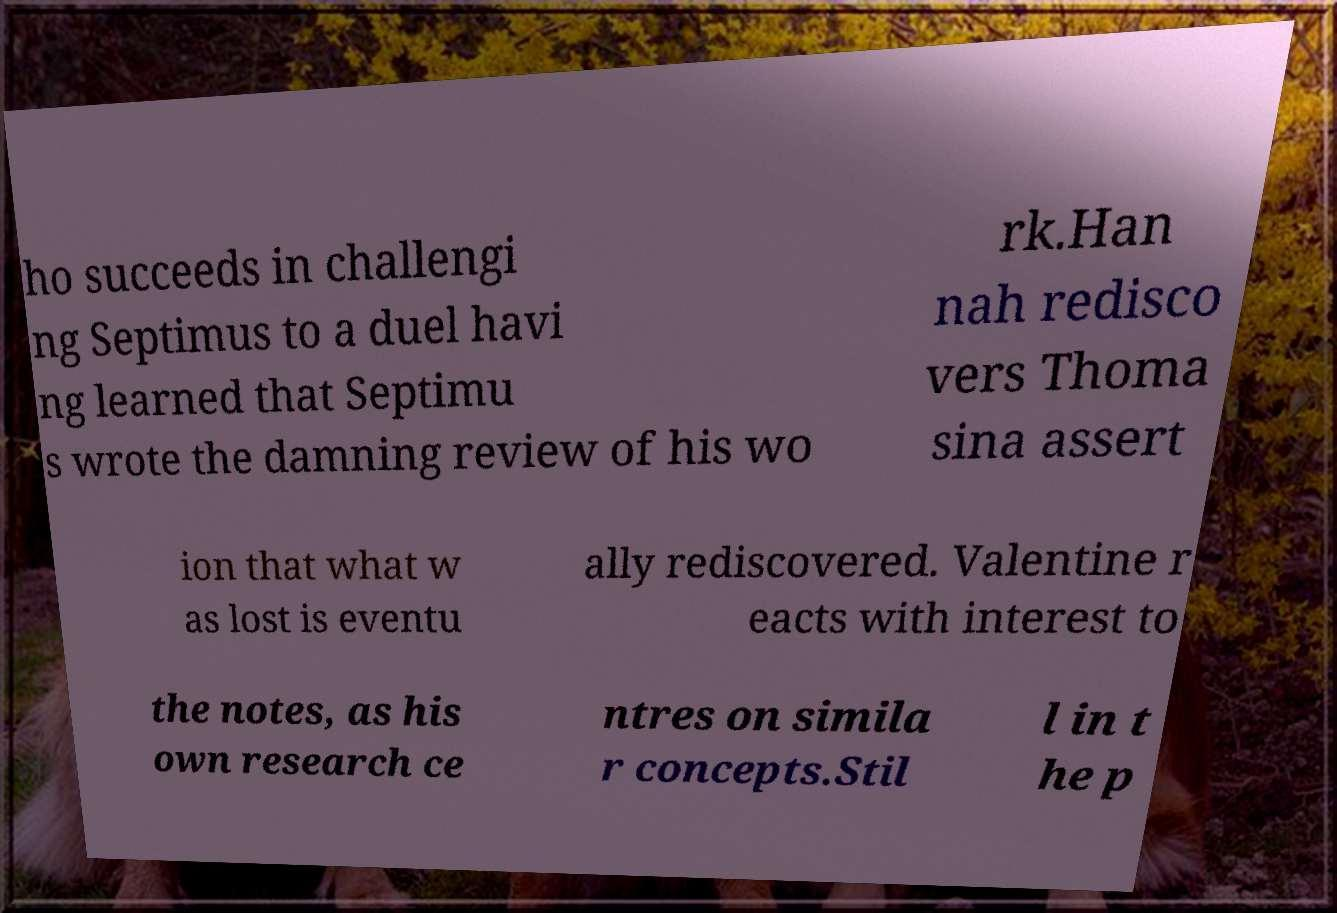There's text embedded in this image that I need extracted. Can you transcribe it verbatim? ho succeeds in challengi ng Septimus to a duel havi ng learned that Septimu s wrote the damning review of his wo rk.Han nah redisco vers Thoma sina assert ion that what w as lost is eventu ally rediscovered. Valentine r eacts with interest to the notes, as his own research ce ntres on simila r concepts.Stil l in t he p 